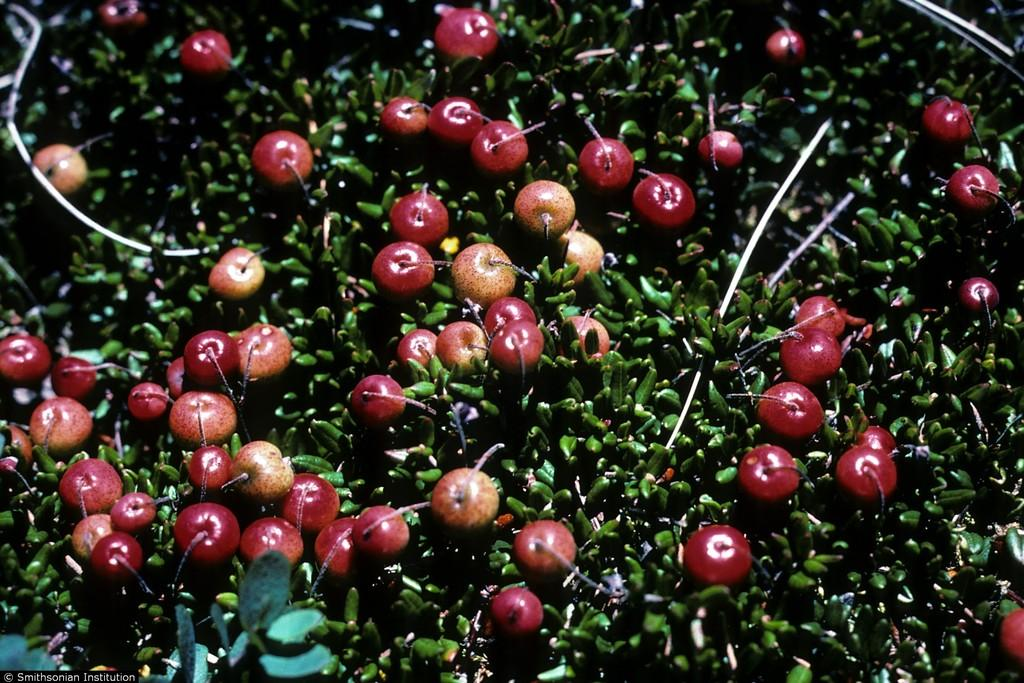What is present in the picture? There is a tree in the picture. What is special about the tree? The tree has fruits. What can be said about the color of the fruits? The fruits are red in color. What type of prose is being recited by the minister in the image? There is no minister or prose present in the image; it features a tree with red fruits. Can you see any worms crawling on the tree in the image? There are no worms visible on the tree in the image. 